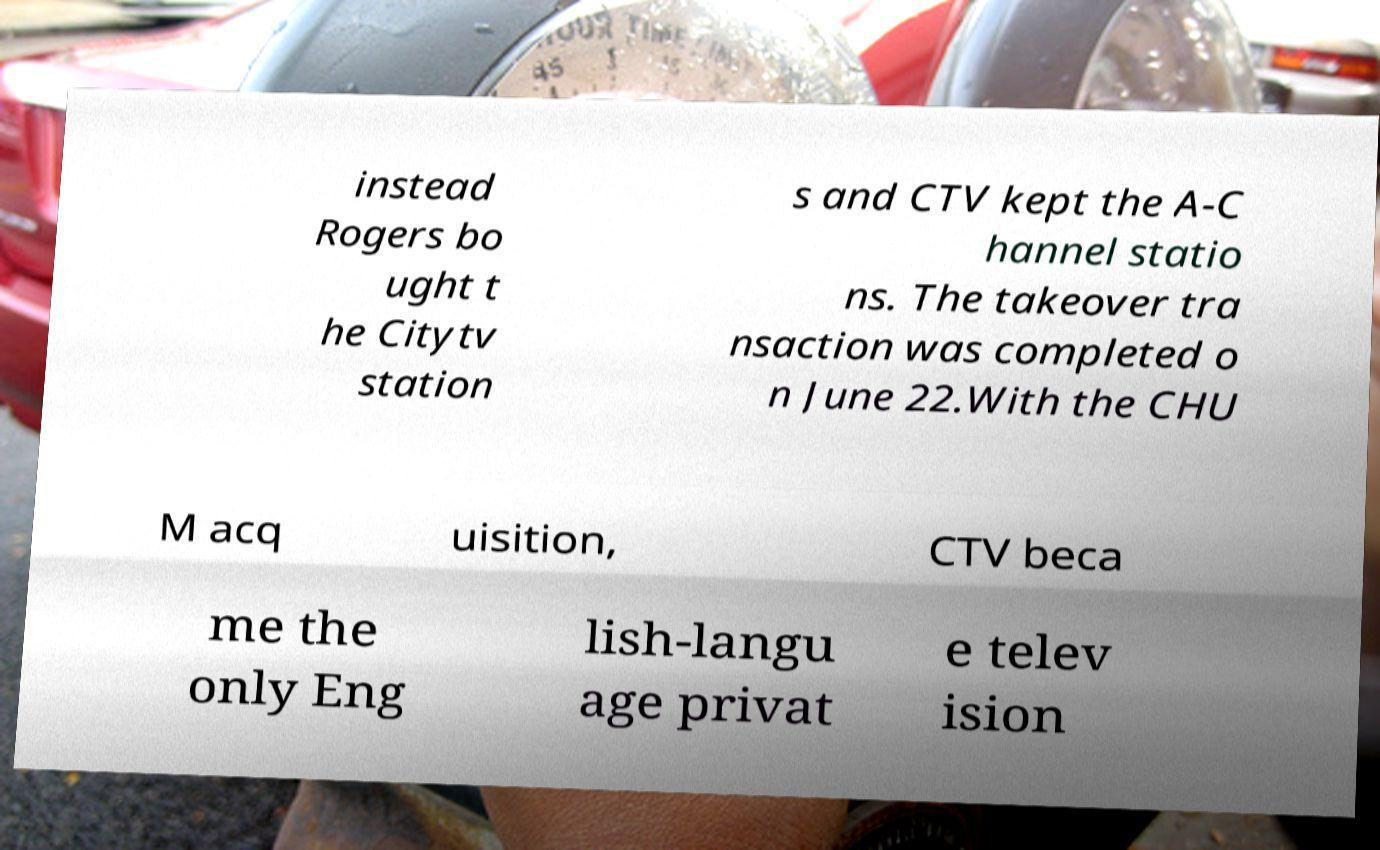For documentation purposes, I need the text within this image transcribed. Could you provide that? instead Rogers bo ught t he Citytv station s and CTV kept the A-C hannel statio ns. The takeover tra nsaction was completed o n June 22.With the CHU M acq uisition, CTV beca me the only Eng lish-langu age privat e telev ision 